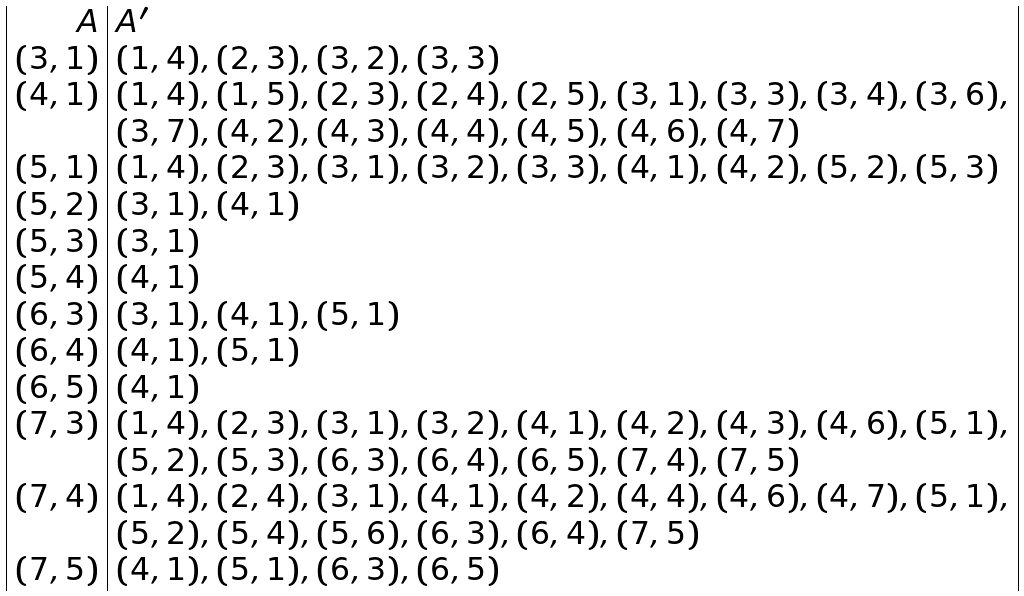<formula> <loc_0><loc_0><loc_500><loc_500>\begin{array} { | r | l | } A & A ^ { \prime } \\ ( 3 , 1 ) & ( 1 , 4 ) , ( 2 , 3 ) , ( 3 , 2 ) , ( 3 , 3 ) \\ ( 4 , 1 ) & ( 1 , 4 ) , ( 1 , 5 ) , ( 2 , 3 ) , ( 2 , 4 ) , ( 2 , 5 ) , ( 3 , 1 ) , ( 3 , 3 ) , ( 3 , 4 ) , ( 3 , 6 ) , \\ & ( 3 , 7 ) , ( 4 , 2 ) , ( 4 , 3 ) , ( 4 , 4 ) , ( 4 , 5 ) , ( 4 , 6 ) , ( 4 , 7 ) \\ ( 5 , 1 ) & ( 1 , 4 ) , ( 2 , 3 ) , ( 3 , 1 ) , ( 3 , 2 ) , ( 3 , 3 ) , ( 4 , 1 ) , ( 4 , 2 ) , ( 5 , 2 ) , ( 5 , 3 ) \\ ( 5 , 2 ) & ( 3 , 1 ) , ( 4 , 1 ) \\ ( 5 , 3 ) & ( 3 , 1 ) \\ ( 5 , 4 ) & ( 4 , 1 ) \\ ( 6 , 3 ) & ( 3 , 1 ) , ( 4 , 1 ) , ( 5 , 1 ) \\ ( 6 , 4 ) & ( 4 , 1 ) , ( 5 , 1 ) \\ ( 6 , 5 ) & ( 4 , 1 ) \\ ( 7 , 3 ) & ( 1 , 4 ) , ( 2 , 3 ) , ( 3 , 1 ) , ( 3 , 2 ) , ( 4 , 1 ) , ( 4 , 2 ) , ( 4 , 3 ) , ( 4 , 6 ) , ( 5 , 1 ) , \\ & ( 5 , 2 ) , ( 5 , 3 ) , ( 6 , 3 ) , ( 6 , 4 ) , ( 6 , 5 ) , ( 7 , 4 ) , ( 7 , 5 ) \\ ( 7 , 4 ) & ( 1 , 4 ) , ( 2 , 4 ) , ( 3 , 1 ) , ( 4 , 1 ) , ( 4 , 2 ) , ( 4 , 4 ) , ( 4 , 6 ) , ( 4 , 7 ) , ( 5 , 1 ) , \\ & ( 5 , 2 ) , ( 5 , 4 ) , ( 5 , 6 ) , ( 6 , 3 ) , ( 6 , 4 ) , ( 7 , 5 ) \\ ( 7 , 5 ) & ( 4 , 1 ) , ( 5 , 1 ) , ( 6 , 3 ) , ( 6 , 5 ) \\ \end{array}</formula> 